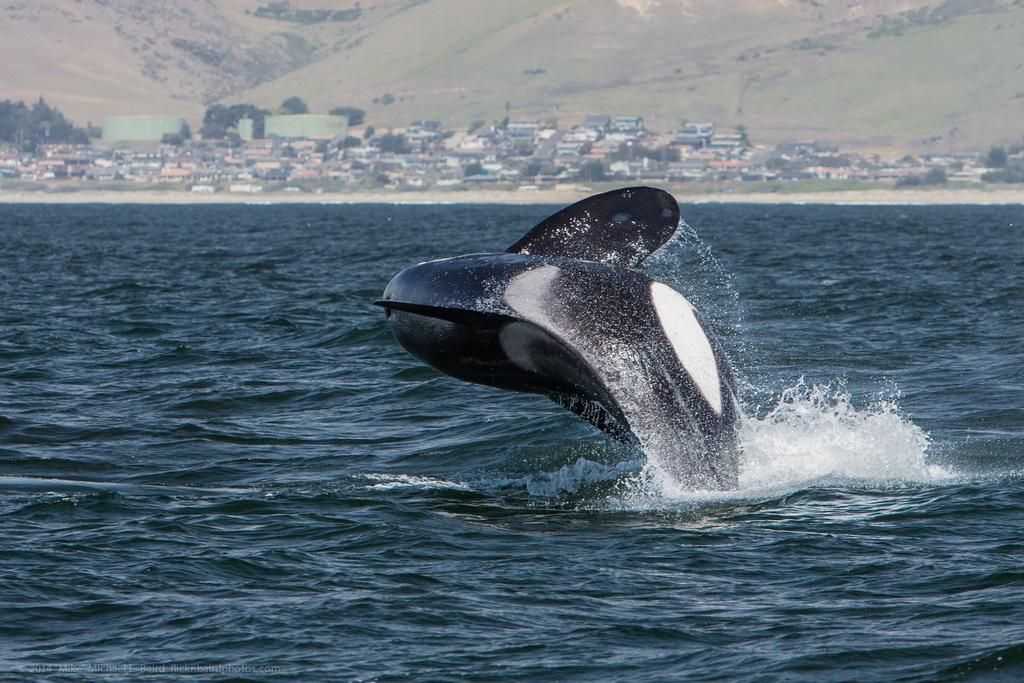Describe this image in one or two sentences. In the center of the image we can see a dolphin jumping into the sea. In the background there are trees and buildings. At the top there are hills. 